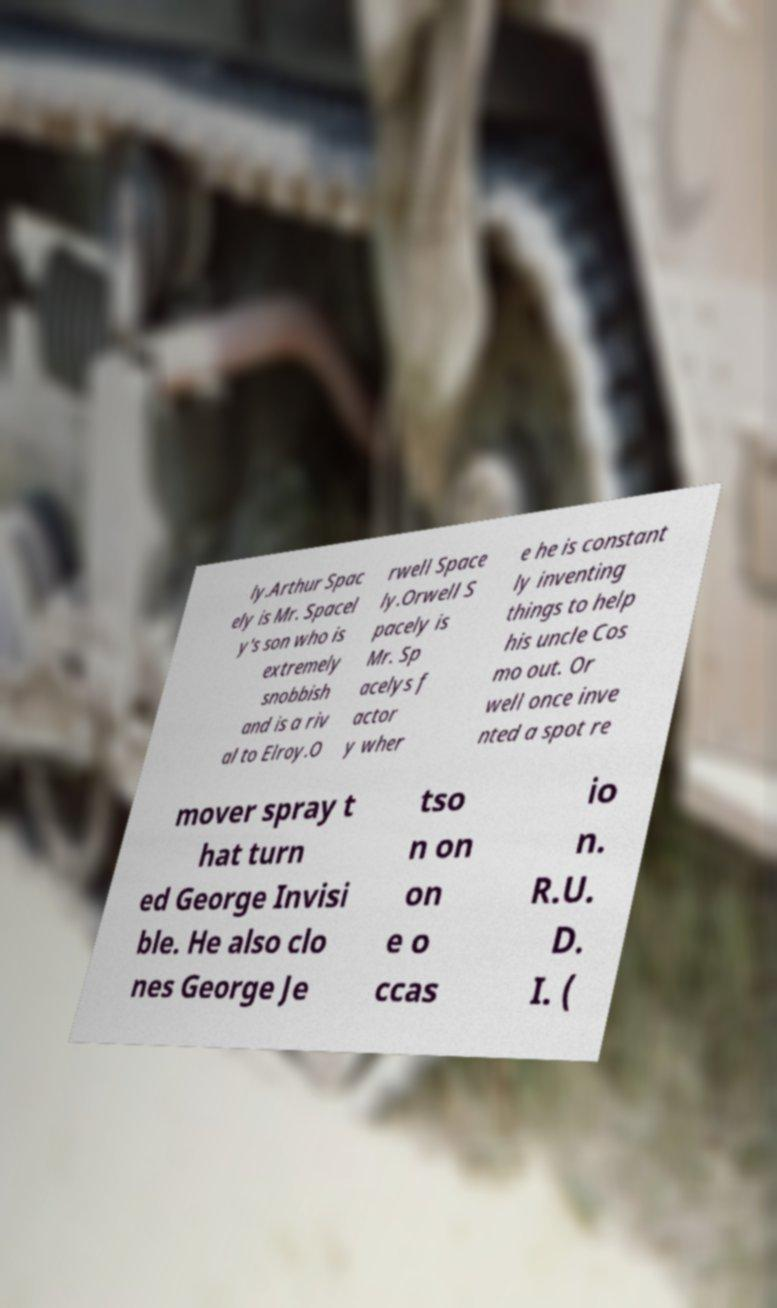Can you accurately transcribe the text from the provided image for me? ly.Arthur Spac ely is Mr. Spacel y's son who is extremely snobbish and is a riv al to Elroy.O rwell Space ly.Orwell S pacely is Mr. Sp acelys f actor y wher e he is constant ly inventing things to help his uncle Cos mo out. Or well once inve nted a spot re mover spray t hat turn ed George Invisi ble. He also clo nes George Je tso n on on e o ccas io n. R.U. D. I. ( 